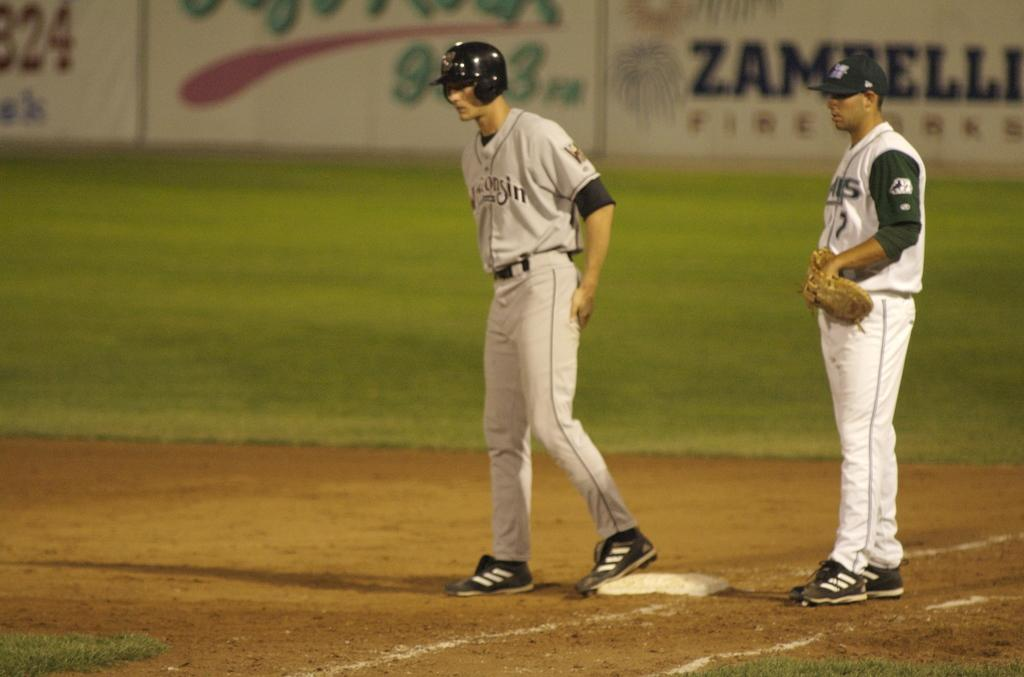<image>
Relay a brief, clear account of the picture shown. Two baseball players are standing at a base with an advertisement for Zambelli behind them. 